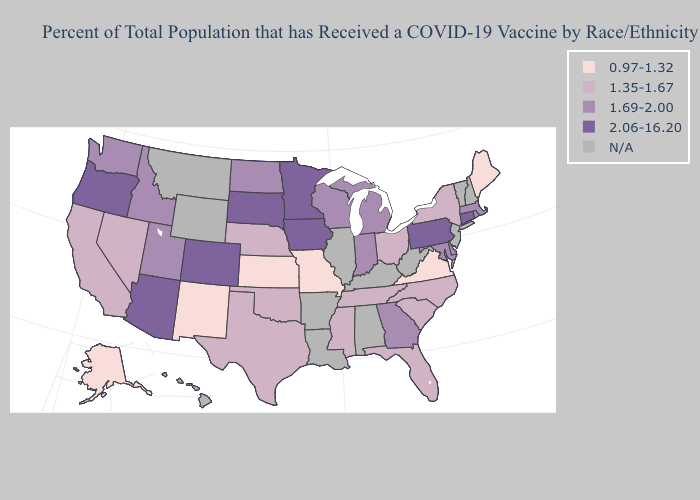What is the highest value in states that border Nebraska?
Write a very short answer. 2.06-16.20. What is the highest value in the USA?
Write a very short answer. 2.06-16.20. Does Utah have the lowest value in the USA?
Answer briefly. No. Does Kansas have the lowest value in the MidWest?
Write a very short answer. Yes. Which states have the highest value in the USA?
Be succinct. Arizona, Colorado, Connecticut, Iowa, Minnesota, Oregon, Pennsylvania, South Dakota. Which states have the highest value in the USA?
Short answer required. Arizona, Colorado, Connecticut, Iowa, Minnesota, Oregon, Pennsylvania, South Dakota. Does Arizona have the highest value in the USA?
Quick response, please. Yes. Does Missouri have the lowest value in the MidWest?
Be succinct. Yes. What is the value of Colorado?
Quick response, please. 2.06-16.20. What is the lowest value in states that border Alabama?
Be succinct. 1.35-1.67. Does South Dakota have the highest value in the USA?
Concise answer only. Yes. Name the states that have a value in the range N/A?
Write a very short answer. Alabama, Arkansas, Hawaii, Illinois, Kentucky, Louisiana, Montana, New Hampshire, New Jersey, Vermont, West Virginia, Wyoming. Does the map have missing data?
Be succinct. Yes. Which states have the lowest value in the USA?
Short answer required. Alaska, Kansas, Maine, Missouri, New Mexico, Virginia. Does Pennsylvania have the highest value in the Northeast?
Short answer required. Yes. 